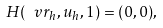<formula> <loc_0><loc_0><loc_500><loc_500>H ( \ v r _ { h } , u _ { h } , 1 ) = ( 0 , 0 ) ,</formula> 